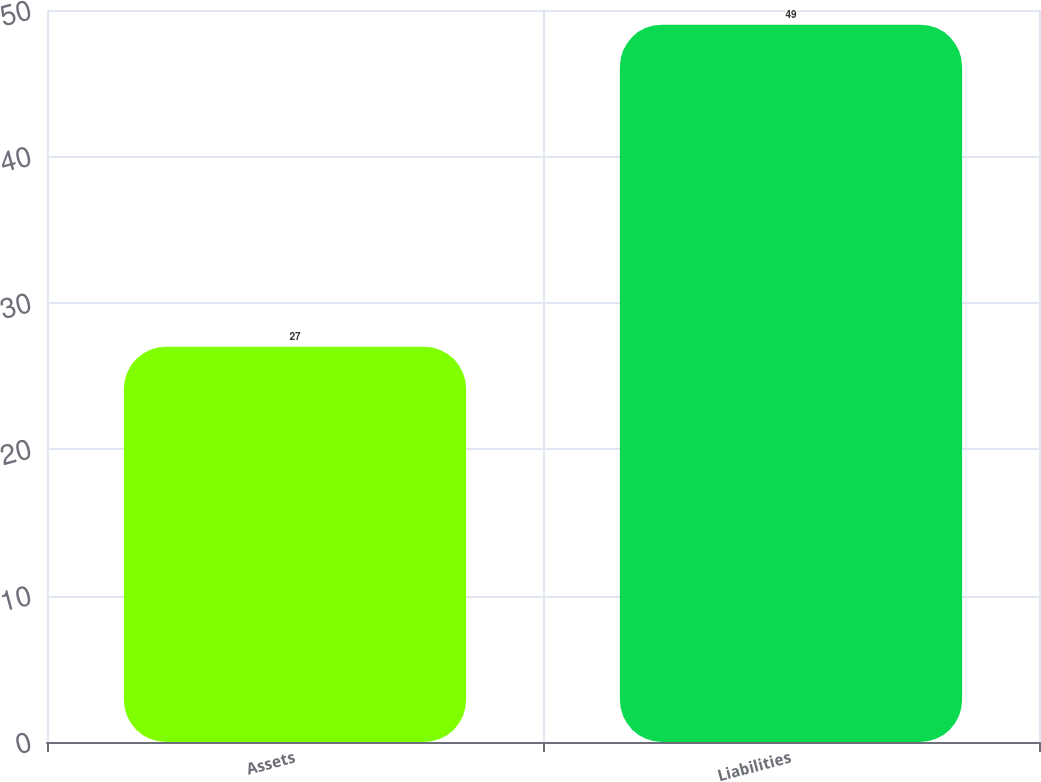Convert chart. <chart><loc_0><loc_0><loc_500><loc_500><bar_chart><fcel>Assets<fcel>Liabilities<nl><fcel>27<fcel>49<nl></chart> 